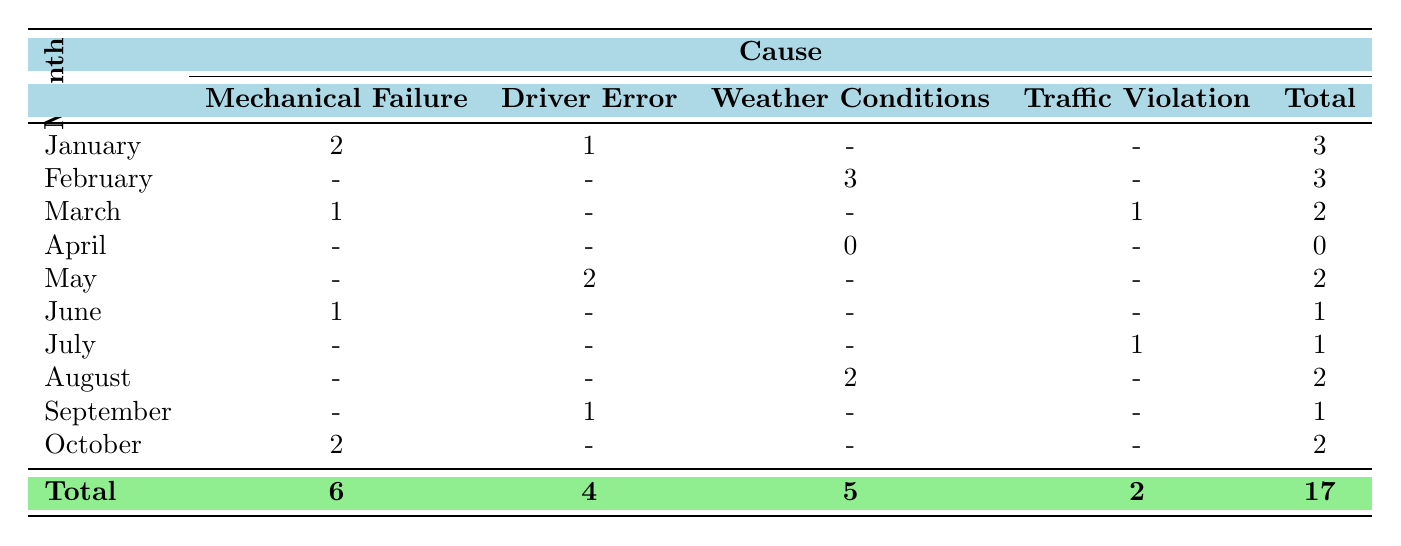What was the total number of incidents reported in March 2023? In March 2023, there were 1 incident due to Mechanical Failure and 1 due to Traffic Violation. Summing these gives a total of 2 incidents reported in March.
Answer: 2 How many incidents were reported in April 2023? In April 2023, the report shows that there were 0 incidents, which is clearly indicated in the table.
Answer: 0 Which month had the highest number of incidents caused by Weather Conditions? The month of February had the highest number of incidents caused by Weather Conditions, with a total of 3 incidents. This can be seen directly from the February row in the table.
Answer: February What is the total number of incidents caused by Driver Error from January to October 2023? Adding the numbers for Driver Error: January (1) + May (2) + September (1) gives a total of 4 incidents due to Driver Error across those months.
Answer: 4 Was there any month with no incidents reported at all? April 2023 had no incidents reported, as indicated by a count of 0 in the table.
Answer: Yes In which month did the Mechanical Failure incidents occur most frequently? Mechanical Failure incidents occurred in January (2), March (1), June (1), and October (2). This indicates that January and October both had the highest frequency with 2 incidents each.
Answer: January and October What was the overall total of Mechanical Failure incidents from January to October 2023? The total for Mechanical Failure incidents is calculated by summing: January (2) + March (1) + June (1) + October (2) = 6 incidents of Mechanical Failure.
Answer: 6 Which cause had the least number of incidents reported across the months? The cause with the least number of reported incidents is Traffic Violation, which totaled only 2 incidents across July and March, as shown in the totals at the bottom of the table.
Answer: Traffic Violation How many months reported incidents due to Weather Conditions? Weather conditions caused incidents in February (3), and August (2). Since there are two months with reported incidents due to Weather Conditions, the answer is 2.
Answer: 2 What is the average number of incidents reported per month for Driver Error? To find the average, we take the total incidents due to Driver Error (4) and divide it by the number of months (10): 4 incidents / 10 months = 0.4 incidents per month on average.
Answer: 0.4 Was there a month in which Driver Error incidents equaled or exceeded Weather Conditions incidents? Yes, in May the Driver Error incidents (2) equaled the Weather Conditions incidents in August (2), thus satisfying the condition of equaling or exceeding.
Answer: Yes 